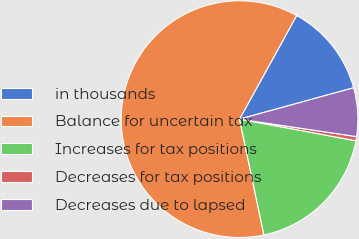Convert chart to OTSL. <chart><loc_0><loc_0><loc_500><loc_500><pie_chart><fcel>in thousands<fcel>Balance for uncertain tax<fcel>Increases for tax positions<fcel>Decreases for tax positions<fcel>Decreases due to lapsed<nl><fcel>12.71%<fcel>61.32%<fcel>18.78%<fcel>0.56%<fcel>6.63%<nl></chart> 